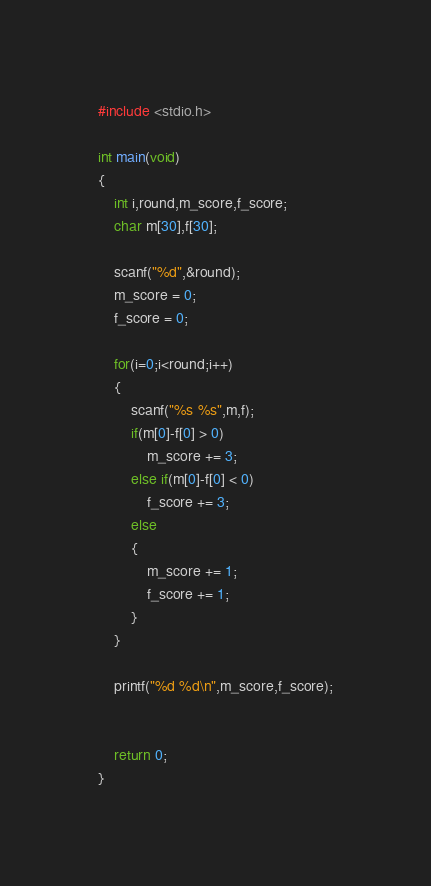<code> <loc_0><loc_0><loc_500><loc_500><_C_>#include <stdio.h>

int main(void)
{
	int i,round,m_score,f_score;
	char m[30],f[30];
	
	scanf("%d",&round);
	m_score = 0;
	f_score = 0;
	
	for(i=0;i<round;i++)
	{
		scanf("%s %s",m,f);
		if(m[0]-f[0] > 0)
			m_score += 3;
		else if(m[0]-f[0] < 0)
			f_score += 3;
		else
		{
			m_score += 1;
			f_score += 1;
		}
	}
	
	printf("%d %d\n",m_score,f_score);
	
	
	return 0;
}</code> 